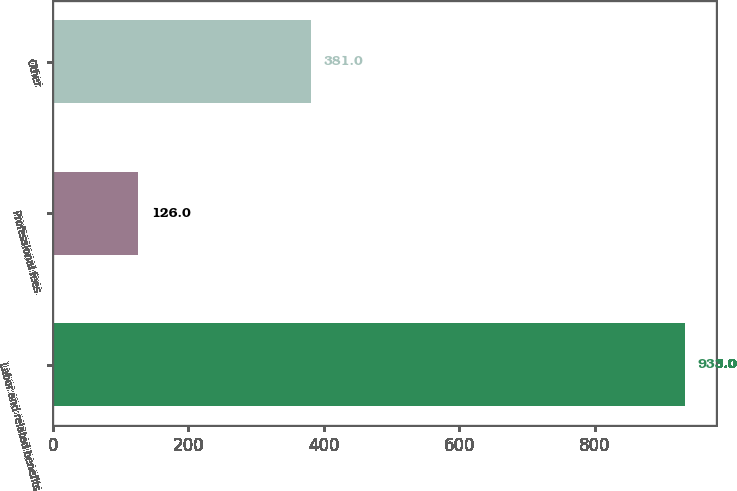Convert chart to OTSL. <chart><loc_0><loc_0><loc_500><loc_500><bar_chart><fcel>Labor and related benefits<fcel>Professional fees<fcel>Other<nl><fcel>933<fcel>126<fcel>381<nl></chart> 